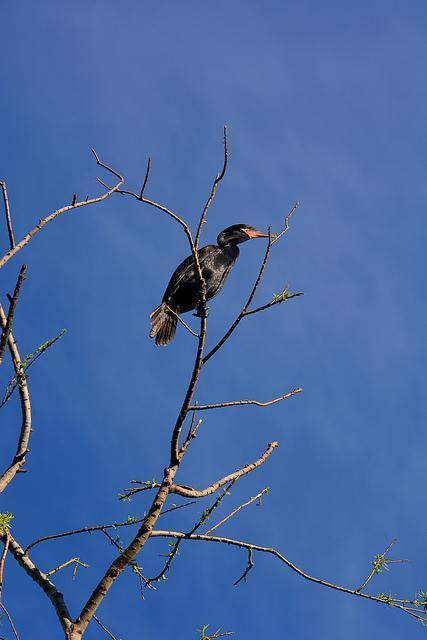How many people have hats on?
Give a very brief answer. 0. 